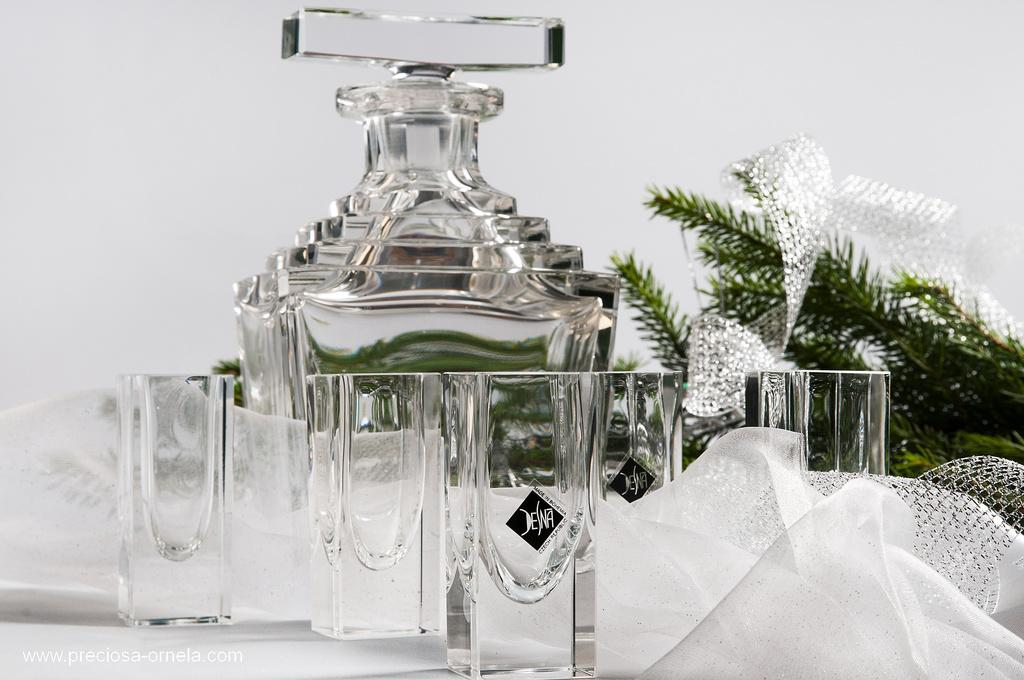What type of objects are made of glass in the image? There are glasses and a glass bottle in the image. What type of natural elements can be seen in the image? There are leaves in the image. What type of material is present in the image? There is cloth in the image. What is the color of the background in the image? The background of the image is white. What type of needle is used to sew the cloth in the image? There is no needle present in the image, and the cloth does not appear to be sewn. What type of reward is given to the person holding the glass bottle in the image? There is no reward present in the image, and no person is holding the glass bottle. 